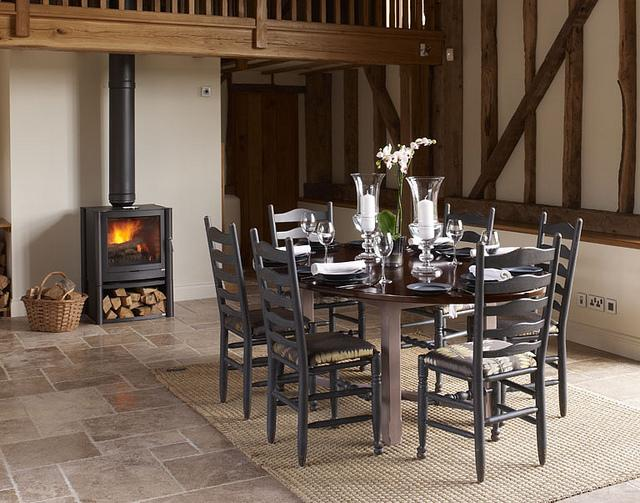What plants help heat this space?

Choices:
A) trees
B) cotton
C) flax
D) bamboo trees 